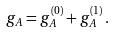Convert formula to latex. <formula><loc_0><loc_0><loc_500><loc_500>g _ { A } = g _ { A } ^ { ( 0 ) } + g _ { A } ^ { ( 1 ) } \, .</formula> 